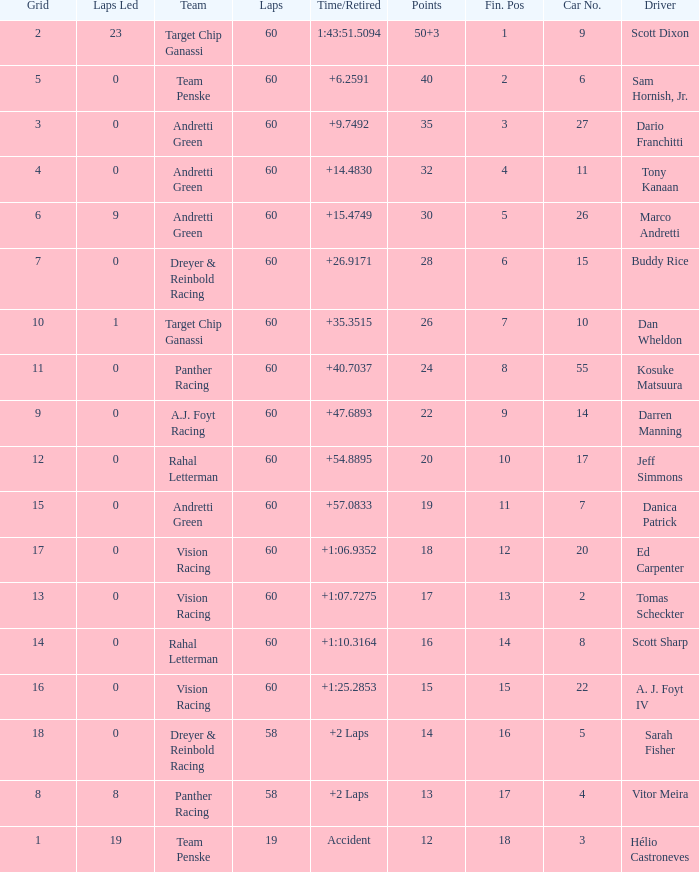Identify the motivation for points totaling 1 Vitor Meira. 